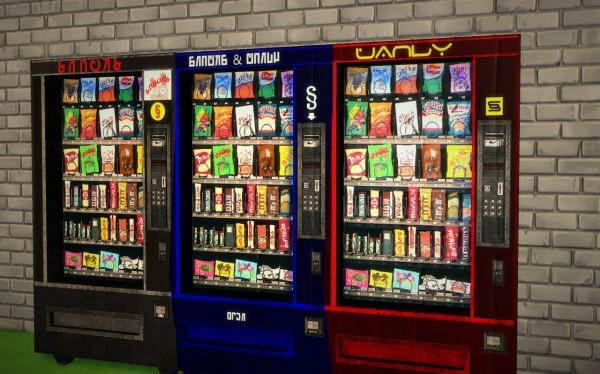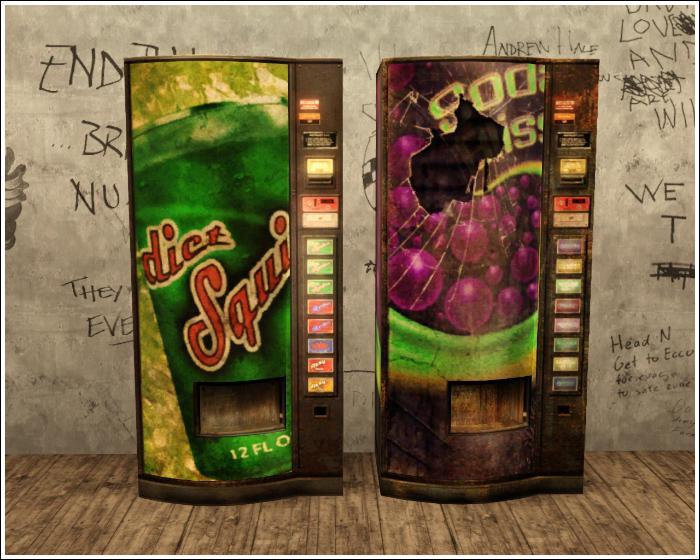The first image is the image on the left, the second image is the image on the right. For the images displayed, is the sentence "Multiple vending machines are displayed in front of a wall of graffiti, in one image." factually correct? Answer yes or no. Yes. The first image is the image on the left, the second image is the image on the right. Assess this claim about the two images: "Exactly five vending machines are depicted.". Correct or not? Answer yes or no. Yes. 